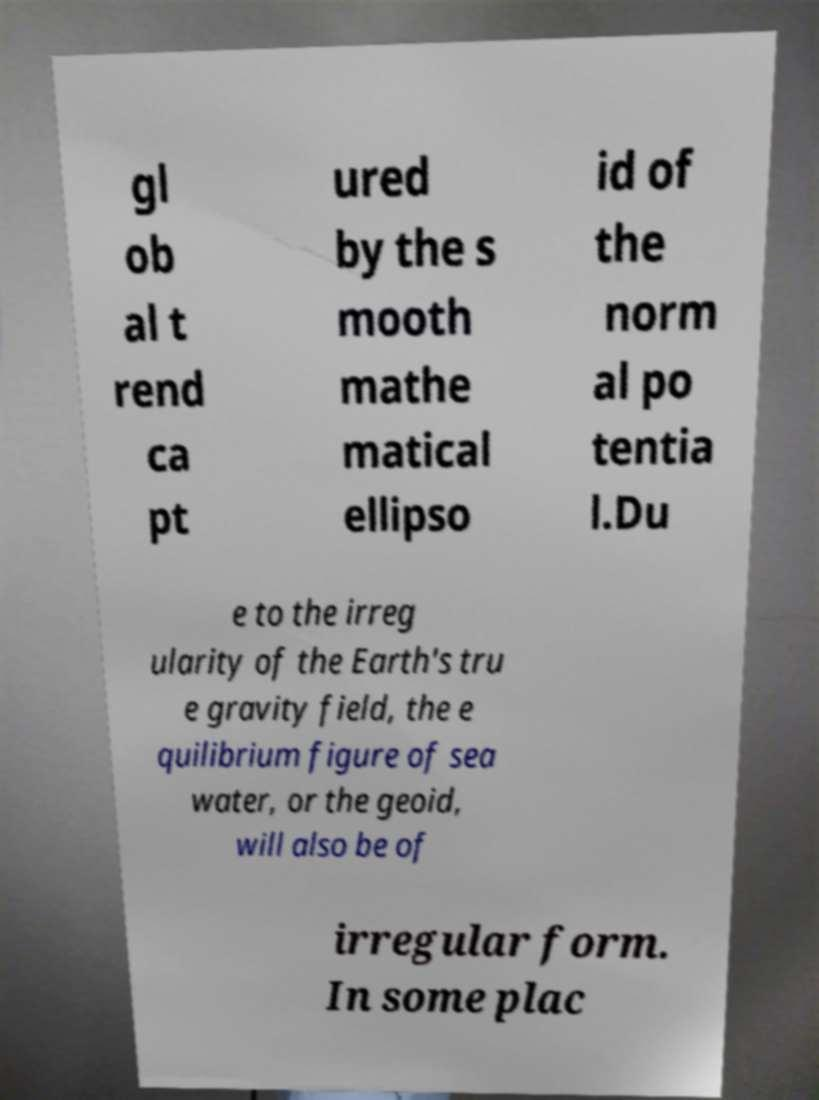Can you accurately transcribe the text from the provided image for me? gl ob al t rend ca pt ured by the s mooth mathe matical ellipso id of the norm al po tentia l.Du e to the irreg ularity of the Earth's tru e gravity field, the e quilibrium figure of sea water, or the geoid, will also be of irregular form. In some plac 